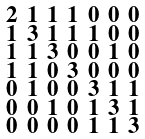<formula> <loc_0><loc_0><loc_500><loc_500>\begin{smallmatrix} 2 & 1 & 1 & 1 & 0 & 0 & 0 \\ 1 & 3 & 1 & 1 & 1 & 0 & 0 \\ 1 & 1 & 3 & 0 & 0 & 1 & 0 \\ 1 & 1 & 0 & 3 & 0 & 0 & 0 \\ 0 & 1 & 0 & 0 & 3 & 1 & 1 \\ 0 & 0 & 1 & 0 & 1 & 3 & 1 \\ 0 & 0 & 0 & 0 & 1 & 1 & 3 \end{smallmatrix}</formula> 